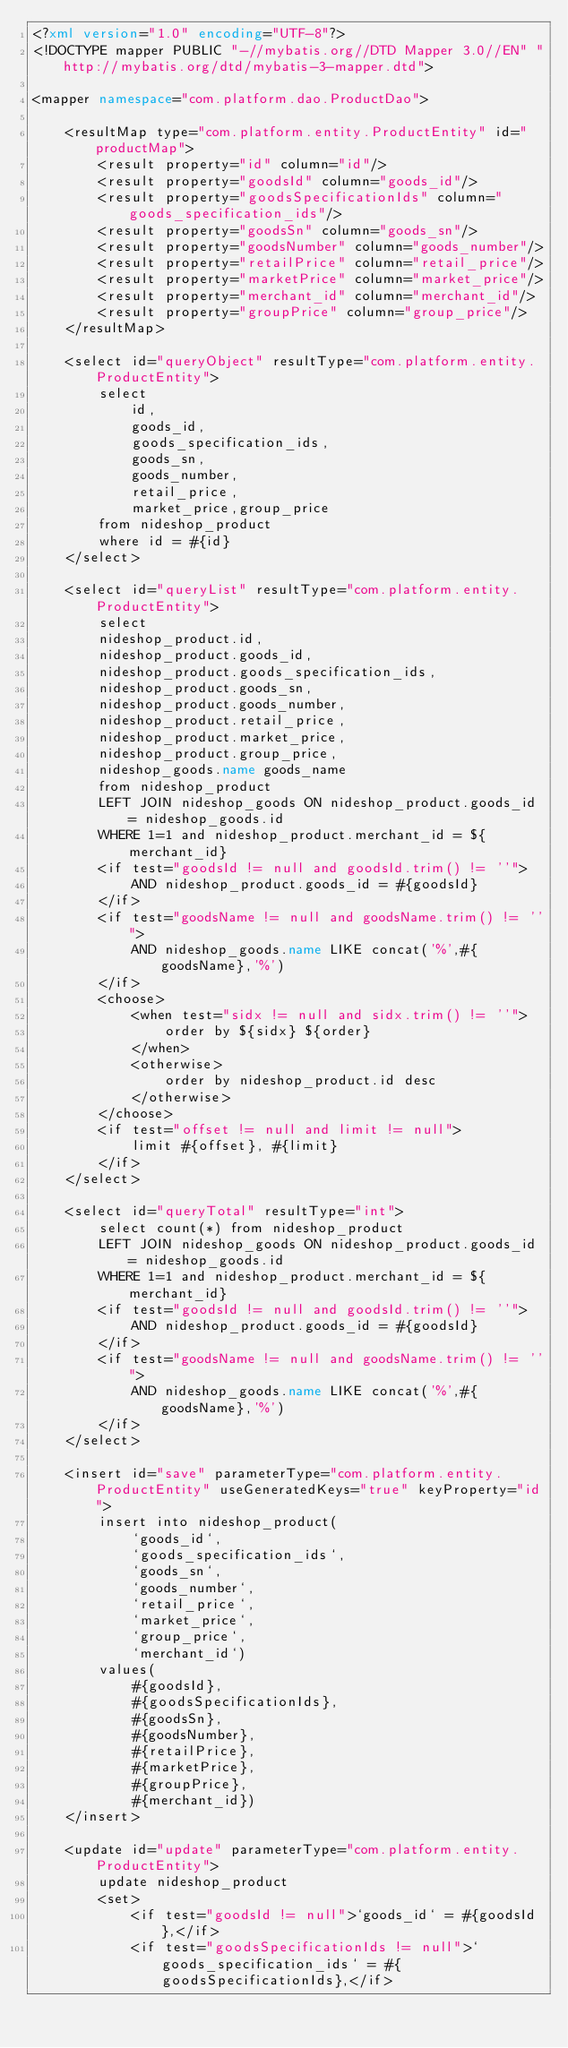<code> <loc_0><loc_0><loc_500><loc_500><_XML_><?xml version="1.0" encoding="UTF-8"?>
<!DOCTYPE mapper PUBLIC "-//mybatis.org//DTD Mapper 3.0//EN" "http://mybatis.org/dtd/mybatis-3-mapper.dtd">

<mapper namespace="com.platform.dao.ProductDao">

    <resultMap type="com.platform.entity.ProductEntity" id="productMap">
        <result property="id" column="id"/>
        <result property="goodsId" column="goods_id"/>
        <result property="goodsSpecificationIds" column="goods_specification_ids"/>
        <result property="goodsSn" column="goods_sn"/>
        <result property="goodsNumber" column="goods_number"/>
        <result property="retailPrice" column="retail_price"/>
        <result property="marketPrice" column="market_price"/>
        <result property="merchant_id" column="merchant_id"/>
        <result property="groupPrice" column="group_price"/>
    </resultMap>

    <select id="queryObject" resultType="com.platform.entity.ProductEntity">
		select
			id,
			goods_id,
			goods_specification_ids,
			goods_sn,
			goods_number,
			retail_price,
			market_price,group_price
		from nideshop_product
		where id = #{id}
	</select>

    <select id="queryList" resultType="com.platform.entity.ProductEntity">
        select
        nideshop_product.id,
        nideshop_product.goods_id,
        nideshop_product.goods_specification_ids,
        nideshop_product.goods_sn,
        nideshop_product.goods_number,
        nideshop_product.retail_price,
        nideshop_product.market_price,
        nideshop_product.group_price,
        nideshop_goods.name goods_name
        from nideshop_product
        LEFT JOIN nideshop_goods ON nideshop_product.goods_id = nideshop_goods.id
        WHERE 1=1 and nideshop_product.merchant_id = ${merchant_id} 
        <if test="goodsId != null and goodsId.trim() != ''">
            AND nideshop_product.goods_id = #{goodsId}
        </if>
        <if test="goodsName != null and goodsName.trim() != ''">
            AND nideshop_goods.name LIKE concat('%',#{goodsName},'%')
        </if>
        <choose>
            <when test="sidx != null and sidx.trim() != ''">
                order by ${sidx} ${order}
            </when>
            <otherwise>
                order by nideshop_product.id desc
            </otherwise>
        </choose>
        <if test="offset != null and limit != null">
            limit #{offset}, #{limit}
        </if>
    </select>

    <select id="queryTotal" resultType="int">
        select count(*) from nideshop_product
        LEFT JOIN nideshop_goods ON nideshop_product.goods_id = nideshop_goods.id
        WHERE 1=1 and nideshop_product.merchant_id = ${merchant_id} 
        <if test="goodsId != null and goodsId.trim() != ''">
            AND nideshop_product.goods_id = #{goodsId}
        </if>
        <if test="goodsName != null and goodsName.trim() != ''">
            AND nideshop_goods.name LIKE concat('%',#{goodsName},'%')
        </if>
    </select>

    <insert id="save" parameterType="com.platform.entity.ProductEntity" useGeneratedKeys="true" keyProperty="id">
		insert into nideshop_product(
			`goods_id`,
			`goods_specification_ids`,
			`goods_sn`,
			`goods_number`,
			`retail_price`,
			`market_price`,
			`group_price`,
			`merchant_id`)
		values(
			#{goodsId},
			#{goodsSpecificationIds},
			#{goodsSn},
			#{goodsNumber},
			#{retailPrice},
			#{marketPrice},
			#{groupPrice},
			#{merchant_id})
	</insert>

    <update id="update" parameterType="com.platform.entity.ProductEntity">
        update nideshop_product
        <set>
            <if test="goodsId != null">`goods_id` = #{goodsId},</if>
            <if test="goodsSpecificationIds != null">`goods_specification_ids` = #{goodsSpecificationIds},</if></code> 